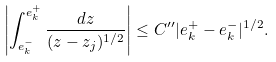Convert formula to latex. <formula><loc_0><loc_0><loc_500><loc_500>\left | \int _ { e _ { k } ^ { - } } ^ { e _ { k } ^ { + } } \frac { d z } { ( z - z _ { j } ) ^ { 1 / 2 } } \right | \leq C ^ { \prime \prime } | e _ { k } ^ { + } - e _ { k } ^ { - } | ^ { 1 / 2 } .</formula> 